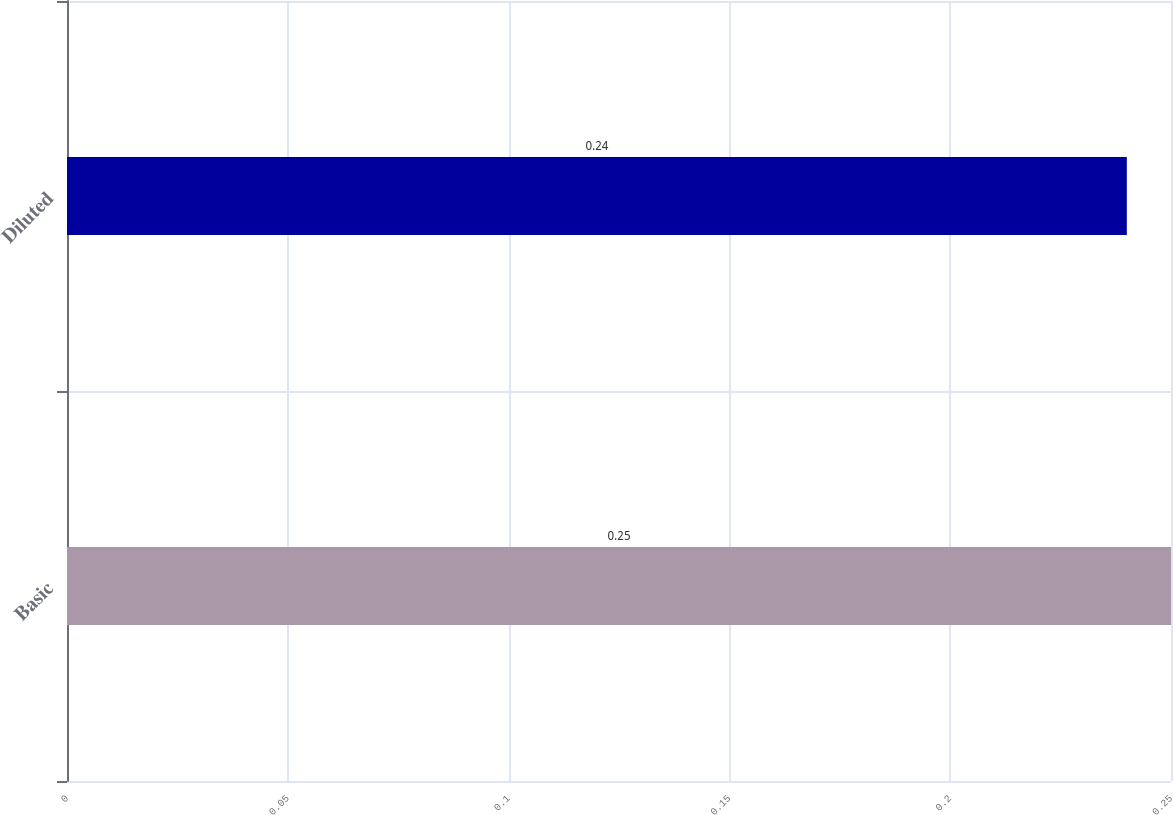Convert chart to OTSL. <chart><loc_0><loc_0><loc_500><loc_500><bar_chart><fcel>Basic<fcel>Diluted<nl><fcel>0.25<fcel>0.24<nl></chart> 